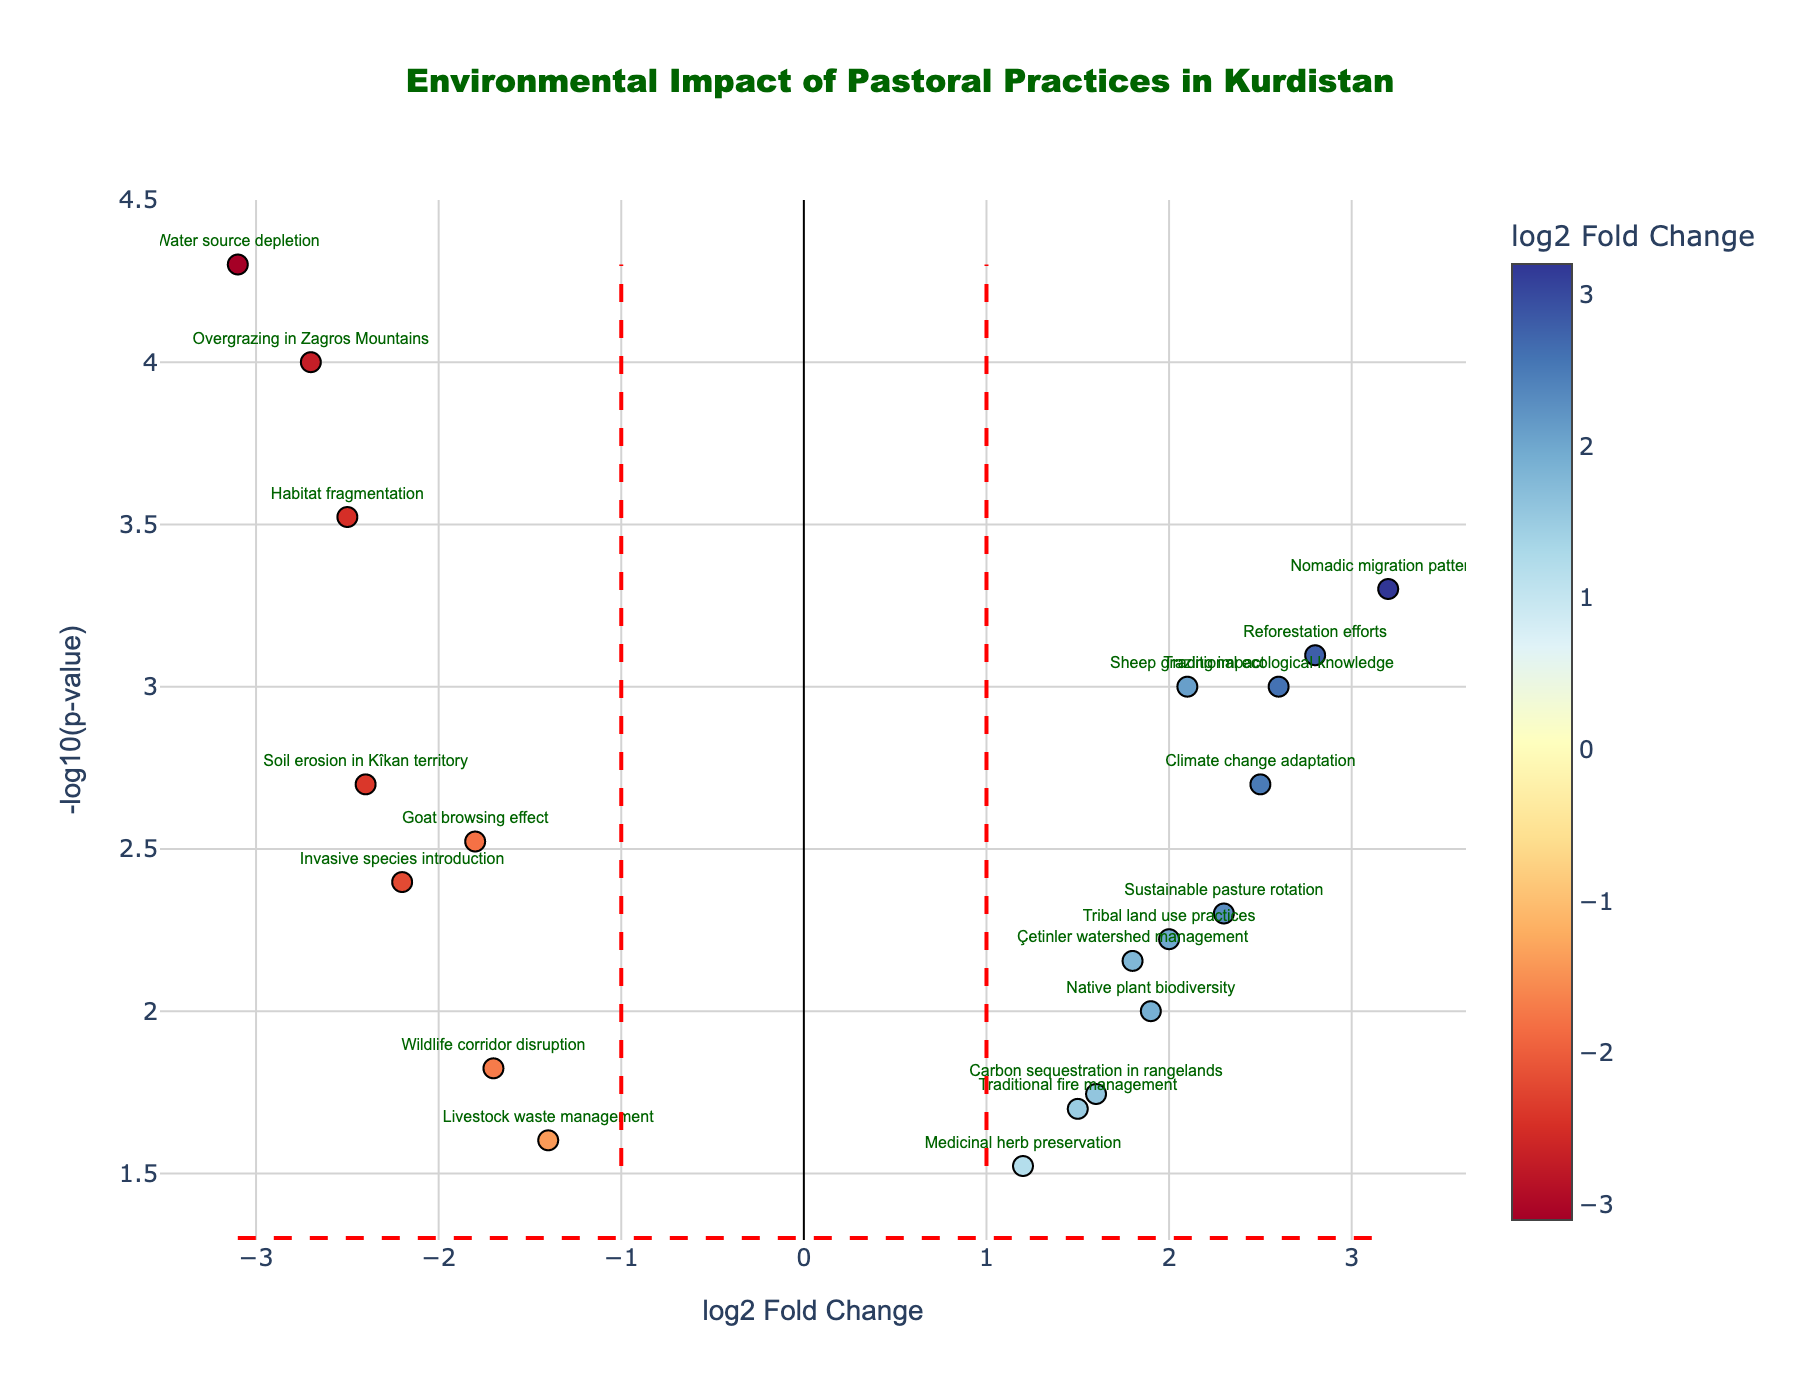What is the title of the Volcano Plot? The title is located at the top of the plot and provides a brief description of the plot's content. In this plot, the title is "Environmental Impact of Pastoral Practices in Kurdistan.”
Answer: Environmental Impact of Pastoral Practices in Kurdistan Which practice has the maximum log2 Fold Change? The maximum log2 Fold Change value can be found by looking for the data point furthest to the right on the x-axis. According to the plot, "Nomadic migration patterns" has the maximum log2 Fold Change of 3.2.
Answer: Nomadic migration patterns Which practices have log2 Fold Change values greater than 2 but less than 3? To find this, look for the data points within the range of 2 to 3 on the x-axis. The practices falling within this range are "Sheep grazing impact", "Reforestation efforts", and "Climate change adaptation.”
Answer: Sheep grazing impact, Reforestation efforts, Climate change adaptation What does the dashed horizontal line represent in the plot? The dashed horizontal line represents a p-value threshold. In this plot, the line is positioned at -log10(0.05). Any data points above this line are considered statistically significant as their p-values are below 0.05.
Answer: p-value threshold 0.05 Which practice exhibits the most statistically significant negative impact (lowest p-value)? The most statistically significant negative impact is represented by the lowest point on the y-axis (the highest -log10(p-value)). "Water source depletion" has the lowest p-value (0.00005), making it the most statistically significant negative impact.
Answer: Water source depletion How many practices have p-values less than 0.005? To answer this, count the number of data points above the line -log10(0.005) on the y-axis since these correspond to p-values less than 0.005. The practices with p-values less than 0.005 include "Sheep grazing impact", "Goat browsing effect", "Nomadic migration patterns", "Overgrazing in Zagros Mountains", "Water source depletion", "Soil erosion in Kîkan territory", "Reforestation efforts", and "Traditional ecological knowledge." Therefore, 8 practices have p-values less than 0.005.
Answer: 8 Compare the impacts of "Native plant biodiversity" and "Invasive species introduction" in terms of their log2 Fold Change values. "Native plant biodiversity" has a log2 Fold Change of 1.9 while "Invasive species introduction" has a log2 Fold Change of -2.2. Comparing these values shows that "Native plant biodiversity" has a positive impact, whereas "Invasive species introduction" has a negative impact.
Answer: Native plant biodiversity: 1.9, Invasive species introduction: -2.2 